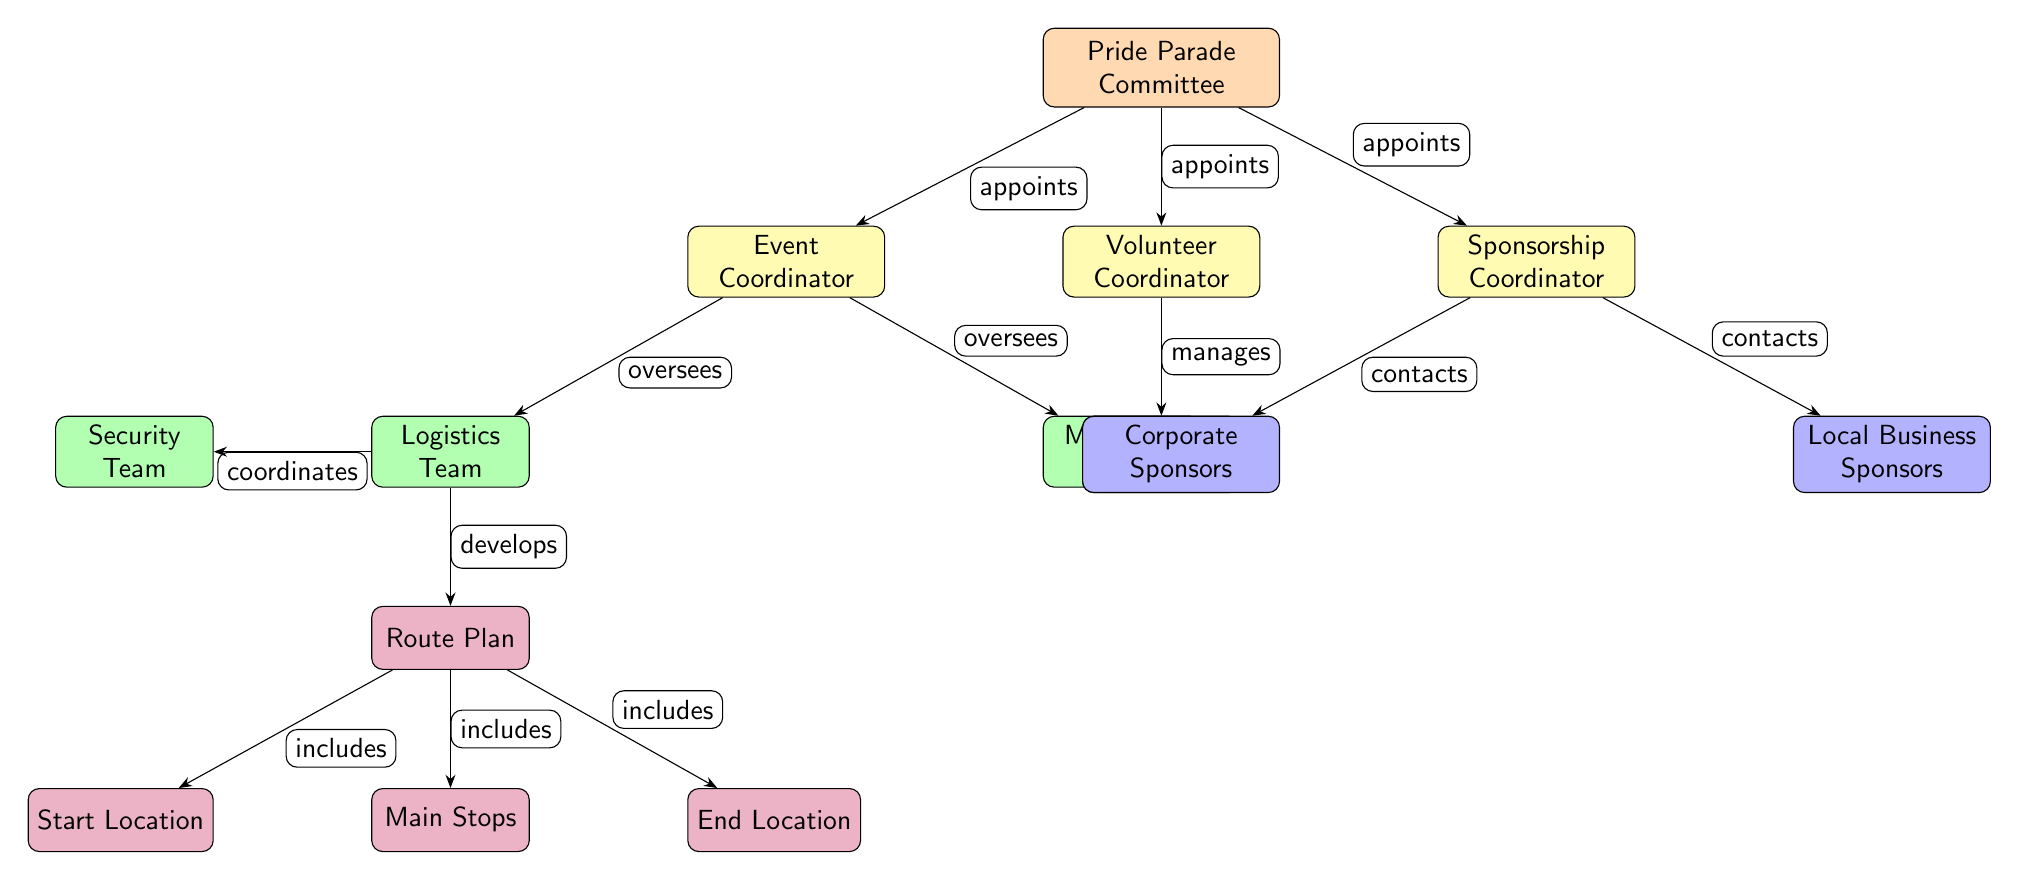What is the top node in the diagram? The top node is labeled as "Pride Parade Committee," which is the main organizing body of the event as indicated in the diagram structure.
Answer: Pride Parade Committee How many coordinators are there in the diagram? There are three coordinators listed: Event Coordinator, Volunteer Coordinator, and Sponsorship Coordinator, which can be counted directly from the branches stemming from the top node.
Answer: 3 Which team is responsible for security? The diagram shows a team labeled "Security Team" that is connected to the Logistics Team, indicating its role in overseeing safety during the parade.
Answer: Security Team What relationship does the Pride Parade Committee have with the Event Coordinator? The diagram indicates that the Pride Parade Committee "appoints" the Event Coordinator, which is shown by the labeled arrow connecting these two nodes.
Answer: appoints Which node details the route plan? The node labeled "Route Plan" explicitly indicates the planning aspect of the parade route and is positioned below the Logistics Team in the flow of the diagram.
Answer: Route Plan How many sponsor types are mentioned in the diagram? There are two types of sponsors mentioned: Corporate Sponsors and Local Business Sponsors, which can be identified by their respective nodes below the Sponsorship Coordinator.
Answer: 2 What does the Logistics Team oversee? The Logistics Team oversees the development of the Route Plan, as shown by the connecting arrows between these two nodes in the diagram.
Answer: Route Plan Which nodes are included under the Route Plan? The Route Plan includes three specific nodes: Start Location, Main Stops, and End Location, which are denoted as part of the plan in the diagram's structure.
Answer: Start Location, Main Stops, End Location Who manages the Volunteer Groups? The Volunteer Coordinator manages the Volunteer Groups based on the directed edge showing the relationship in the diagram structure.
Answer: Volunteer Coordinator 